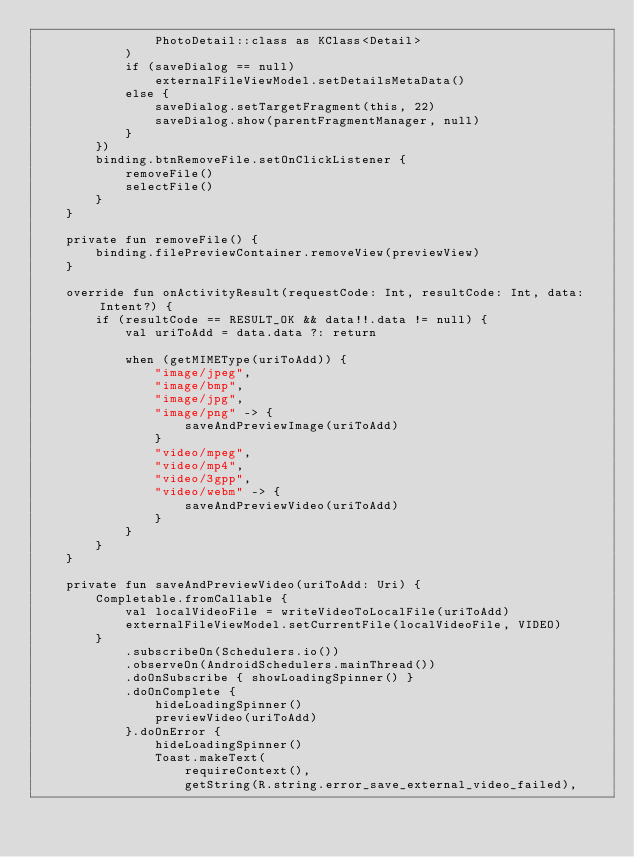Convert code to text. <code><loc_0><loc_0><loc_500><loc_500><_Kotlin_>                PhotoDetail::class as KClass<Detail>
            )
            if (saveDialog == null)
                externalFileViewModel.setDetailsMetaData()
            else {
                saveDialog.setTargetFragment(this, 22)
                saveDialog.show(parentFragmentManager, null)
            }
        })
        binding.btnRemoveFile.setOnClickListener {
            removeFile()
            selectFile()
        }
    }

    private fun removeFile() {
        binding.filePreviewContainer.removeView(previewView)
    }

    override fun onActivityResult(requestCode: Int, resultCode: Int, data: Intent?) {
        if (resultCode == RESULT_OK && data!!.data != null) {
            val uriToAdd = data.data ?: return

            when (getMIMEType(uriToAdd)) {
                "image/jpeg",
                "image/bmp",
                "image/jpg",
                "image/png" -> {
                    saveAndPreviewImage(uriToAdd)
                }
                "video/mpeg",
                "video/mp4",
                "video/3gpp",
                "video/webm" -> {
                    saveAndPreviewVideo(uriToAdd)
                }
            }
        }
    }

    private fun saveAndPreviewVideo(uriToAdd: Uri) {
        Completable.fromCallable {
            val localVideoFile = writeVideoToLocalFile(uriToAdd)
            externalFileViewModel.setCurrentFile(localVideoFile, VIDEO)
        }
            .subscribeOn(Schedulers.io())
            .observeOn(AndroidSchedulers.mainThread())
            .doOnSubscribe { showLoadingSpinner() }
            .doOnComplete {
                hideLoadingSpinner()
                previewVideo(uriToAdd)
            }.doOnError {
                hideLoadingSpinner()
                Toast.makeText(
                    requireContext(),
                    getString(R.string.error_save_external_video_failed),</code> 